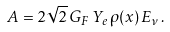<formula> <loc_0><loc_0><loc_500><loc_500>A = 2 \sqrt { 2 } \, G _ { F } \, Y _ { e } \, \rho ( x ) \, E _ { \nu } \, .</formula> 